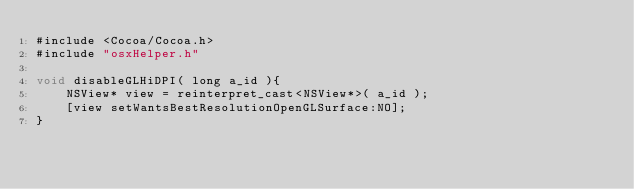Convert code to text. <code><loc_0><loc_0><loc_500><loc_500><_ObjectiveC_>#include <Cocoa/Cocoa.h>
#include "osxHelper.h"

void disableGLHiDPI( long a_id ){
    NSView* view = reinterpret_cast<NSView*>( a_id );
    [view setWantsBestResolutionOpenGLSurface:NO];
}
</code> 